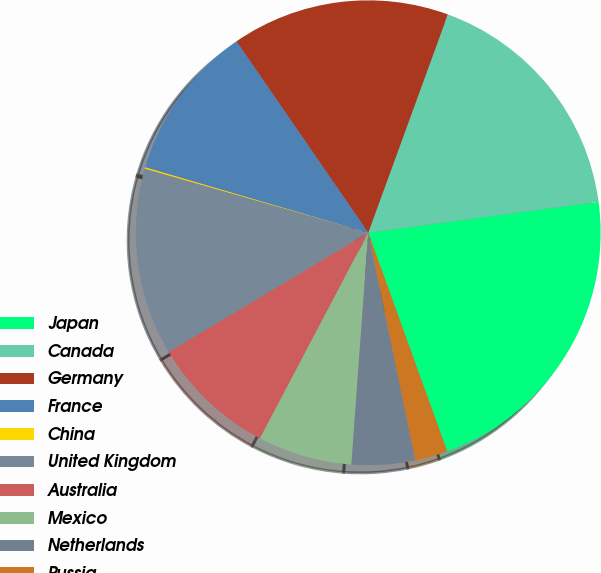Convert chart to OTSL. <chart><loc_0><loc_0><loc_500><loc_500><pie_chart><fcel>Japan<fcel>Canada<fcel>Germany<fcel>France<fcel>China<fcel>United Kingdom<fcel>Australia<fcel>Mexico<fcel>Netherlands<fcel>Russia<nl><fcel>21.61%<fcel>17.31%<fcel>15.16%<fcel>10.86%<fcel>0.11%<fcel>13.01%<fcel>8.71%<fcel>6.56%<fcel>4.41%<fcel>2.26%<nl></chart> 